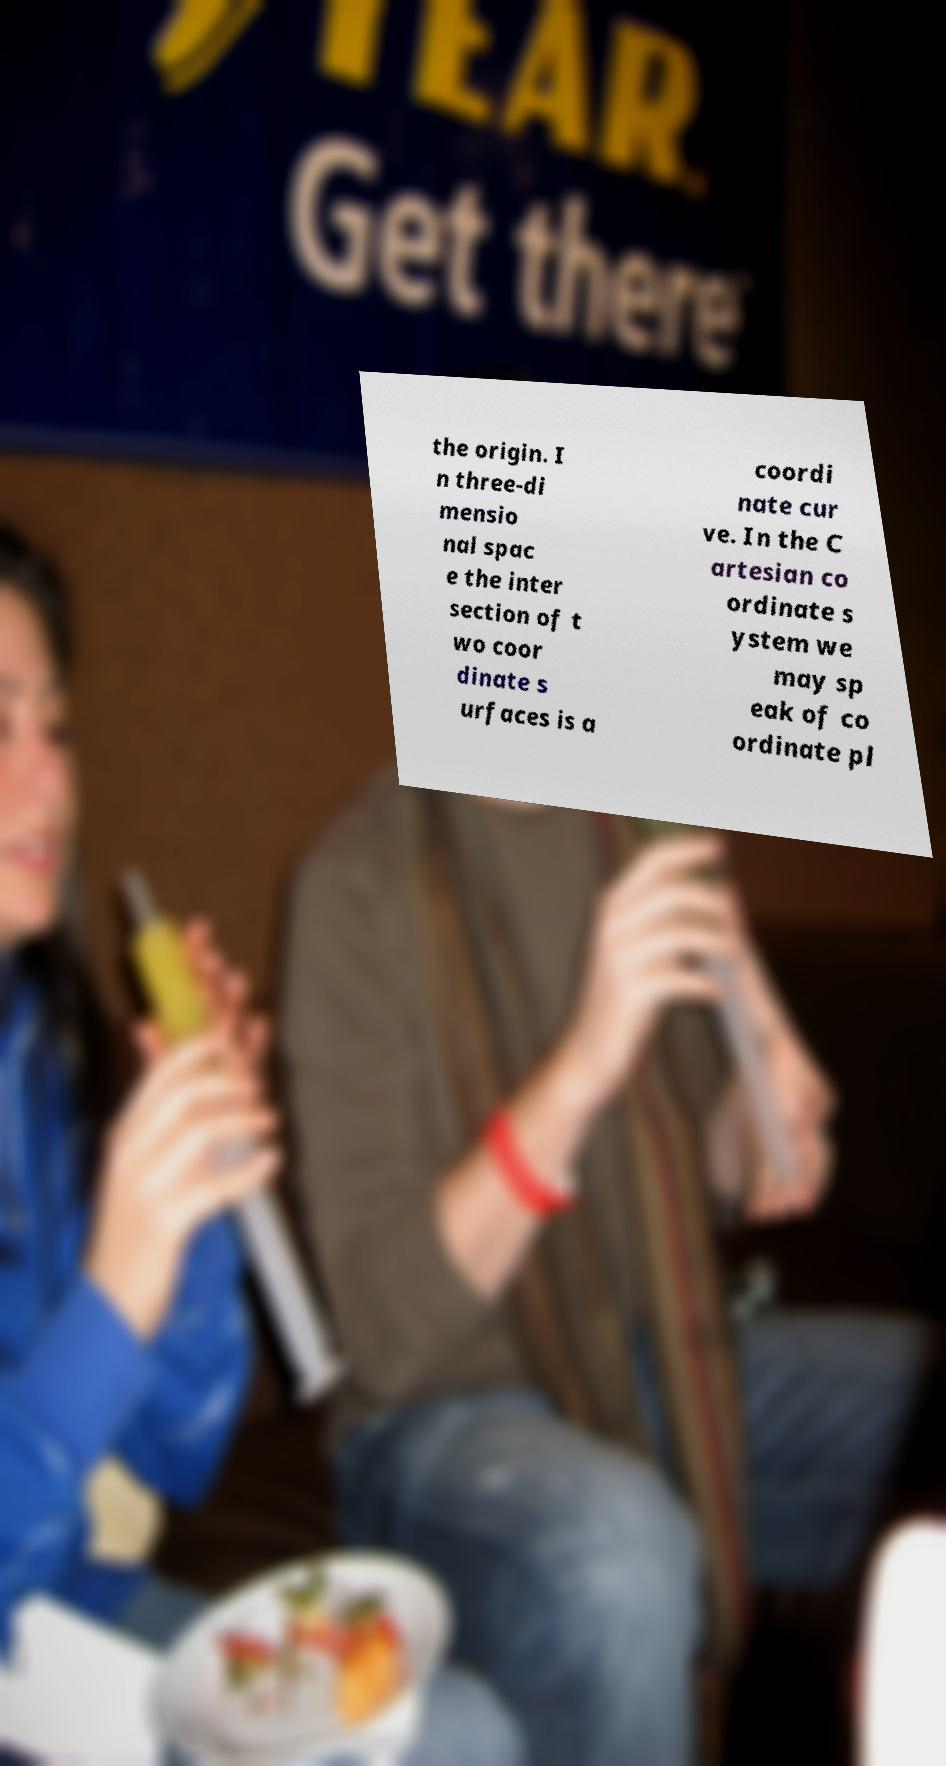For documentation purposes, I need the text within this image transcribed. Could you provide that? the origin. I n three-di mensio nal spac e the inter section of t wo coor dinate s urfaces is a coordi nate cur ve. In the C artesian co ordinate s ystem we may sp eak of co ordinate pl 